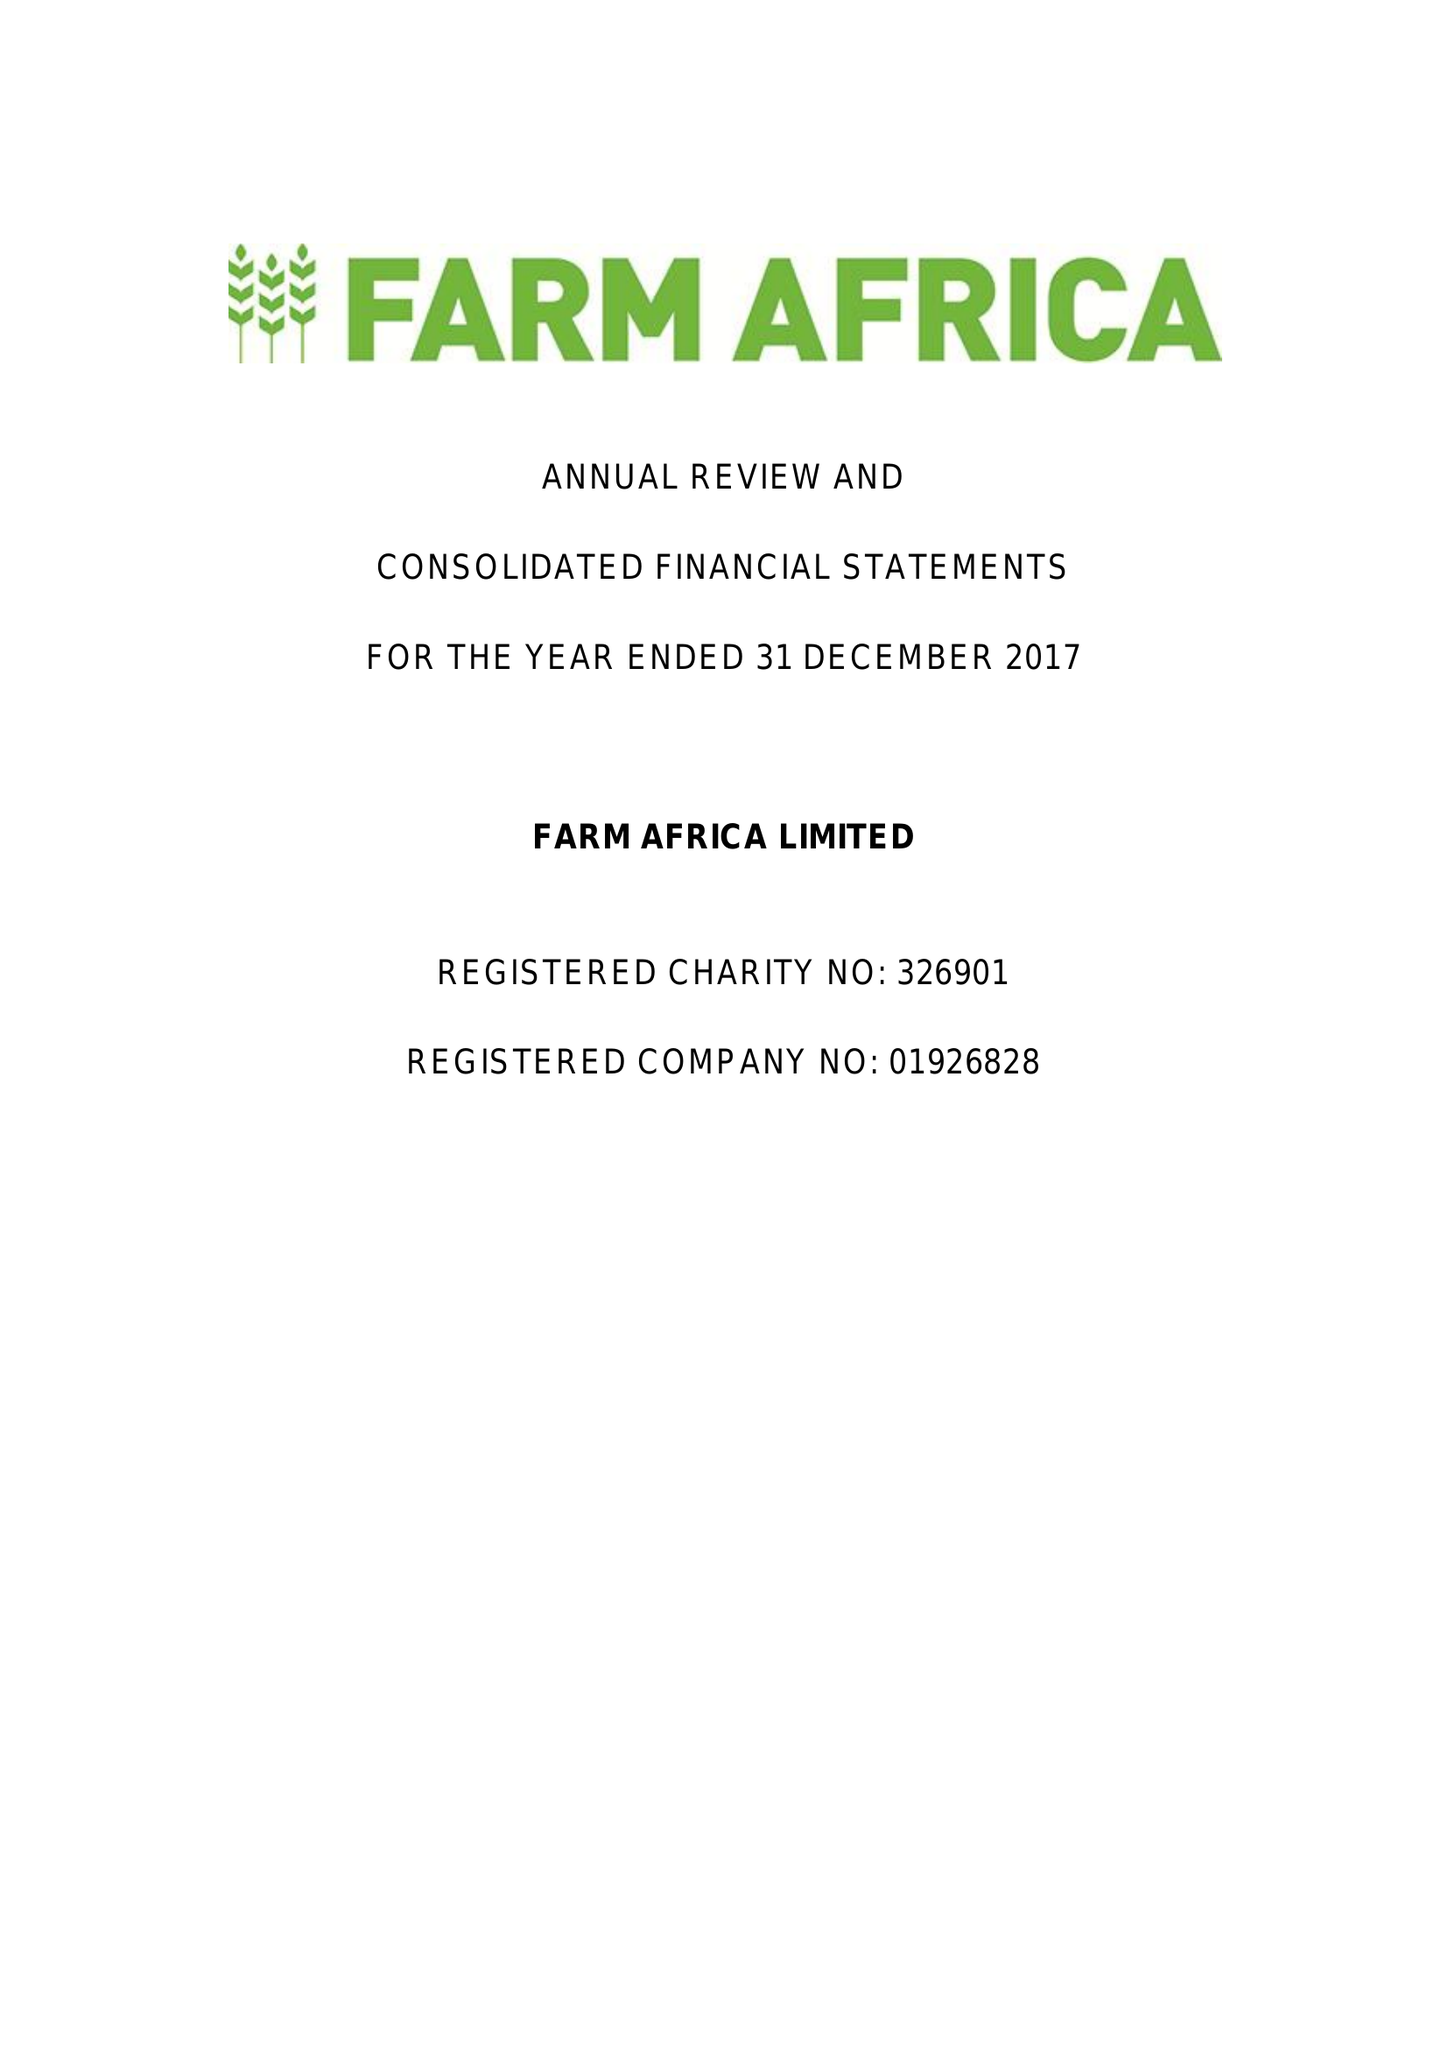What is the value for the income_annually_in_british_pounds?
Answer the question using a single word or phrase. 14716000.00 